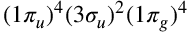Convert formula to latex. <formula><loc_0><loc_0><loc_500><loc_500>( 1 \pi _ { u } ) ^ { 4 } ( 3 \sigma _ { u } ) ^ { 2 } ( 1 \pi _ { g } ) ^ { 4 }</formula> 